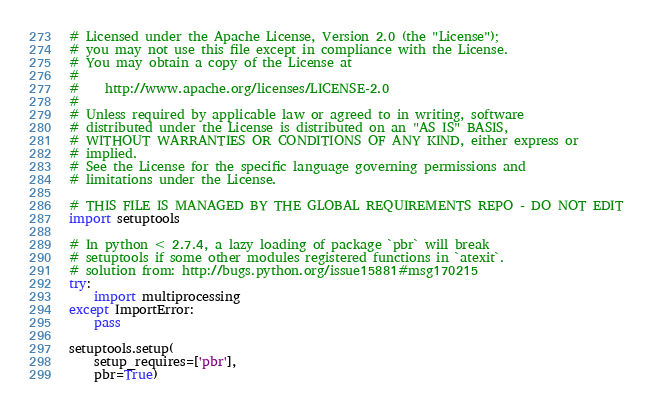<code> <loc_0><loc_0><loc_500><loc_500><_Python_># Licensed under the Apache License, Version 2.0 (the "License");
# you may not use this file except in compliance with the License.
# You may obtain a copy of the License at
#
#    http://www.apache.org/licenses/LICENSE-2.0
#
# Unless required by applicable law or agreed to in writing, software
# distributed under the License is distributed on an "AS IS" BASIS,
# WITHOUT WARRANTIES OR CONDITIONS OF ANY KIND, either express or
# implied.
# See the License for the specific language governing permissions and
# limitations under the License.

# THIS FILE IS MANAGED BY THE GLOBAL REQUIREMENTS REPO - DO NOT EDIT
import setuptools

# In python < 2.7.4, a lazy loading of package `pbr` will break
# setuptools if some other modules registered functions in `atexit`.
# solution from: http://bugs.python.org/issue15881#msg170215
try:
    import multiprocessing
except ImportError:
    pass

setuptools.setup(
    setup_requires=['pbr'],
    pbr=True)
</code> 